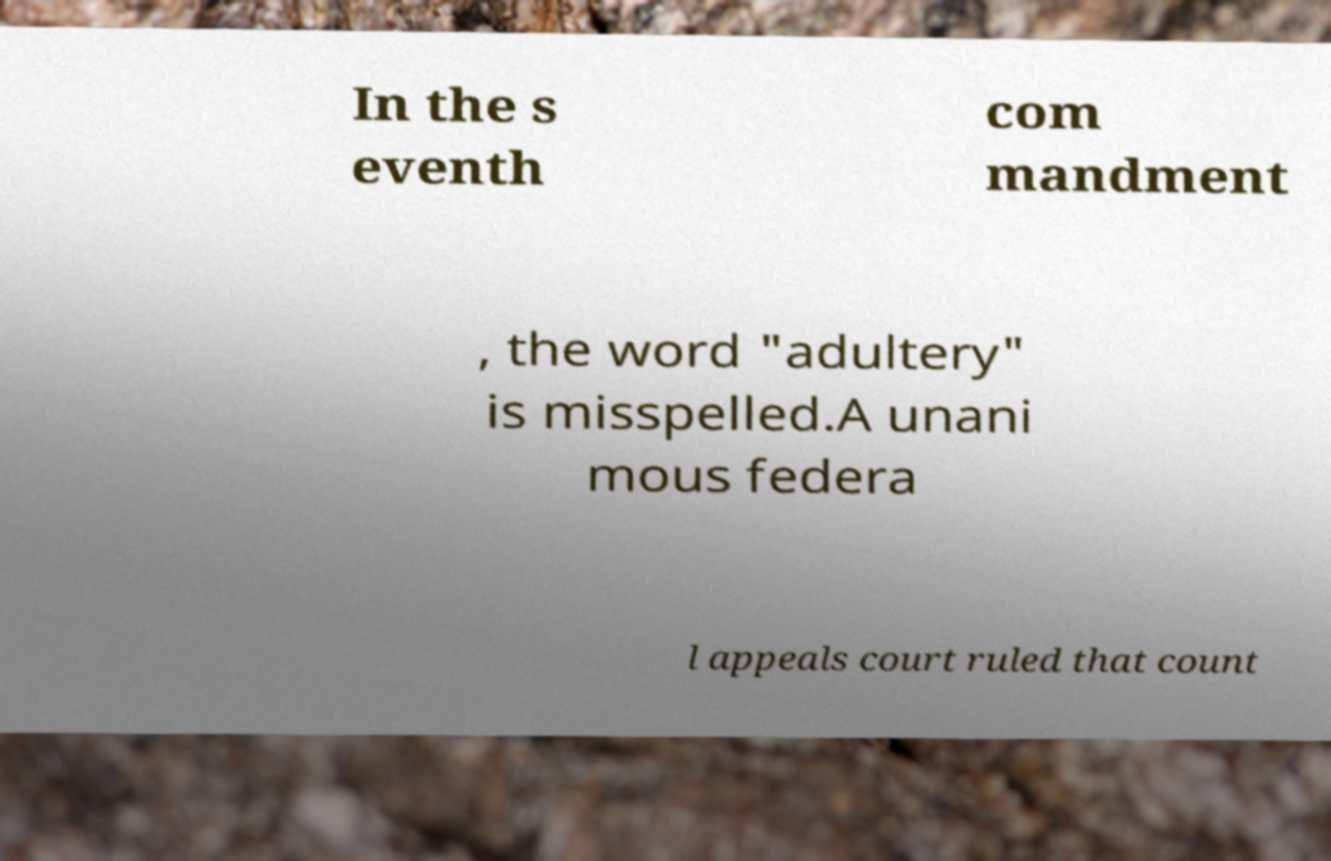What messages or text are displayed in this image? I need them in a readable, typed format. In the s eventh com mandment , the word "adultery" is misspelled.A unani mous federa l appeals court ruled that count 